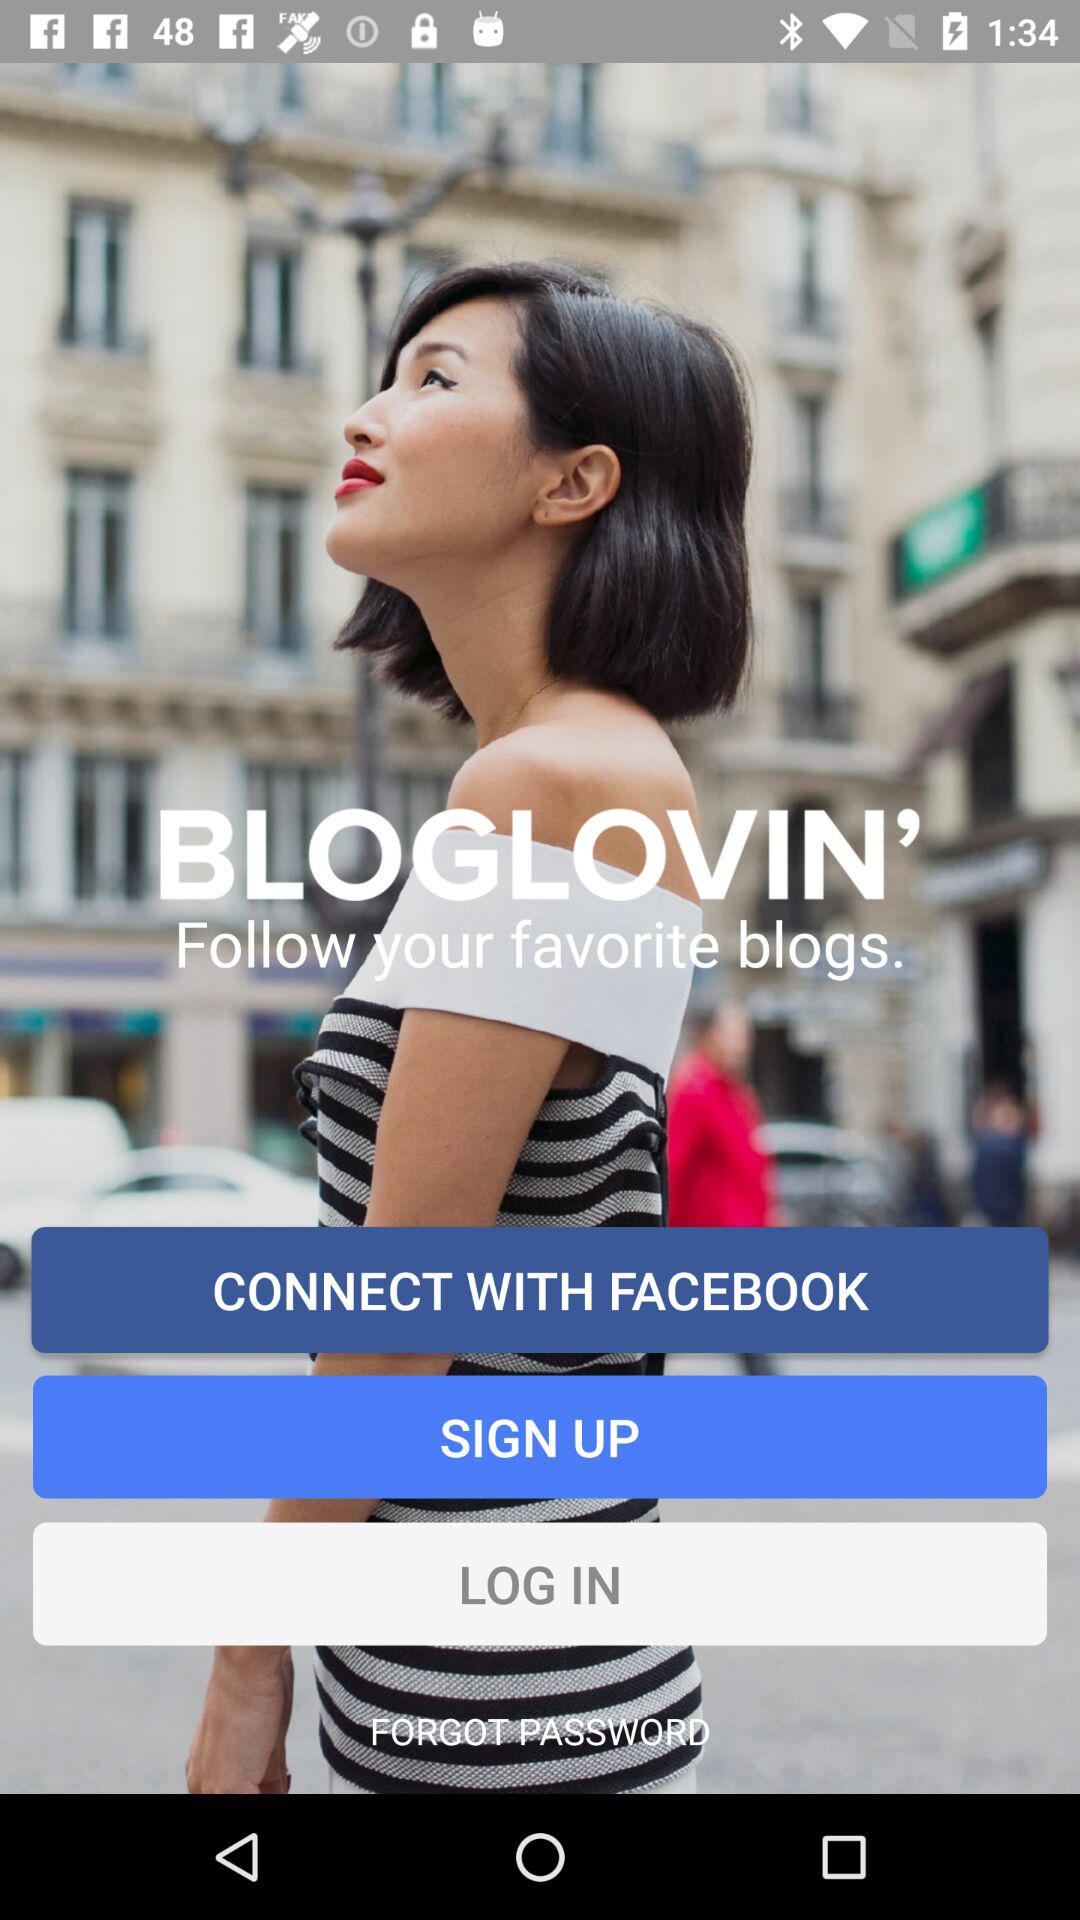What is the mood conveyed by the image's background and the subject's expression? The image portrays a sense of upbeat, thoughtful contemplation, perhaps reflective of lifestyle inspiration typical of blog content found on platforms like Bloglovin'. The backdrop features an urban scene with blurred architectural elements, suggestive of dynamic city life. The subject's upward gaze and slight smile exude a mood of optimism and forward-thinking, aligning with the innovative and social nature of Bloglovin'. 